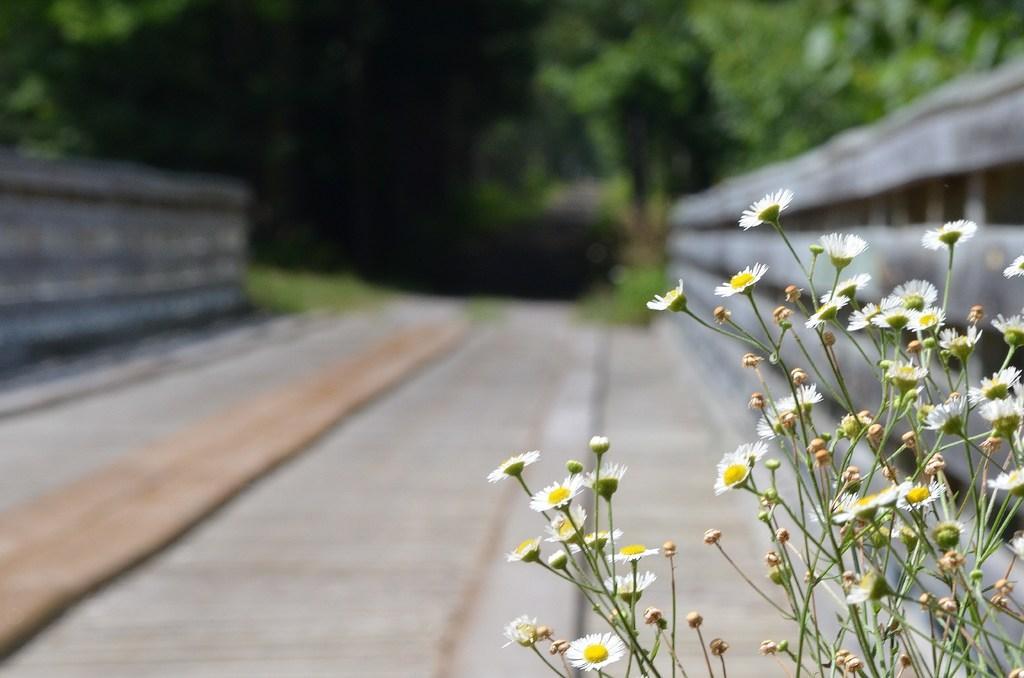Describe this image in one or two sentences. On the right side of the picture we can see white flowers. This is a road. In the background we can see trees. 